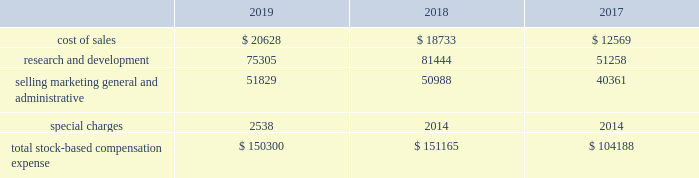Expected term 2014 the company uses historical employee exercise and option expiration data to estimate the expected term assumption for the black-scholes grant-date valuation .
The company believes that this historical data is currently the best estimate of the expected term of a new option , and that generally its employees exhibit similar exercise behavior .
Risk-free interest rate 2014 the yield on zero-coupon u.s .
Treasury securities for a period that is commensurate with the expected term assumption is used as the risk-free interest rate .
Expected dividend yield 2014 expected dividend yield is calculated by annualizing the cash dividend declared by the company 2019s board of directors for the current quarter and dividing that result by the closing stock price on the date of grant .
Until such time as the company 2019s board of directors declares a cash dividend for an amount that is different from the current quarter 2019s cash dividend , the current dividend will be used in deriving this assumption .
Cash dividends are not paid on options , restricted stock or restricted stock units .
In connection with the acquisition , the company granted restricted stock awards to replace outstanding restricted stock awards of linear employees .
These restricted stock awards entitle recipients to voting and nonforfeitable dividend rights from the date of grant .
Stock-based compensation expensexp p the amount of stock-based compensation expense recognized during a period is based on the value of the awards that are ultimately expected to vest .
Forfeitures are estimated at the time of grant and revised , if necessary , in subsequent periods if actual forfeitures differ from those estimates .
The term 201cforfeitures 201d is distinct from 201ccancellations 201d or 201cexpirations 201d and represents only the unvested portion of the surrendered stock-based award .
Based on an analysis of its historical forfeitures , the company has applied an annual forfeitureff rate of 5.0% ( 5.0 % ) to all unvested stock-based awards as of november 2 , 2019 .
This analysis will be re-evaluated quarterly and the forfeiture rate will be adjusted as necessary .
Ultimately , the actual expense recognized over the vesting period will only be for those awards that vest .
Total stock-based compensation expense recognized is as follows: .
As of november 2 , 2019 and november 3 , 2018 , the company capitalized $ 6.8 million and $ 7.1 million , respectively , of stock-based compensation in inventory .
Additional paid-in-capital ( apic ) pp poolp p ( ) the company adopted asu 2016-09 during fiscal 2018 .
Asu 2016-09 eliminated the apic pool and requires that excess tax benefits and tax deficiencies be recorded in the income statement when awards are settled .
As a result of this adoption the company recorded total excess tax benefits of $ 28.7 million and $ 26.2 million in fiscal 2019 and fiscal 2018 , respectively , from its stock-based compensation payments within income tax expense in its consolidated statements of income .
For fiscal 2017 , the apic pool represented the excess tax benefits related to stock-based compensation that were available to absorb future tax deficiencies .
If the amount of future tax deficiencies was greater than the available apic pool , the company recorded the excess as income tax expense in its consolidated statements of income .
For fiscal 2017 , the company had a sufficient apic pool to cover any tax deficiencies recorded and as a result , these deficiencies did not affect its results of operations .
Analog devices , inc .
Notes to consolidated financial statements 2014 ( continued ) .
What is the growth rate in the cost of sales in 2019? 
Computations: ((20628 - 18733) / 18733)
Answer: 0.10116. 